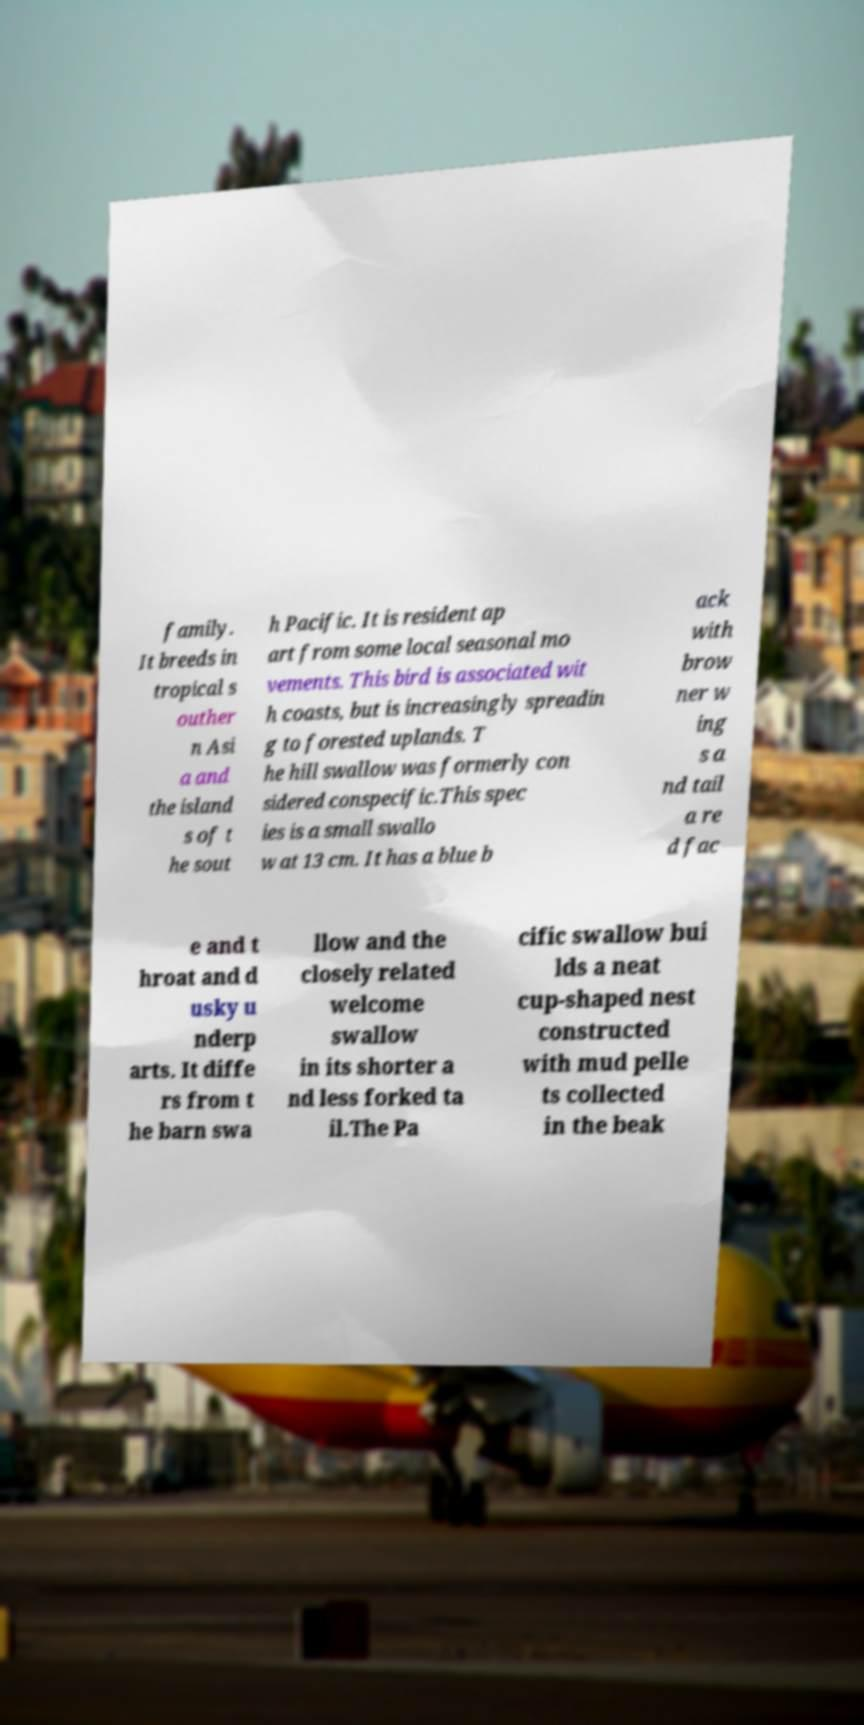I need the written content from this picture converted into text. Can you do that? family. It breeds in tropical s outher n Asi a and the island s of t he sout h Pacific. It is resident ap art from some local seasonal mo vements. This bird is associated wit h coasts, but is increasingly spreadin g to forested uplands. T he hill swallow was formerly con sidered conspecific.This spec ies is a small swallo w at 13 cm. It has a blue b ack with brow ner w ing s a nd tail a re d fac e and t hroat and d usky u nderp arts. It diffe rs from t he barn swa llow and the closely related welcome swallow in its shorter a nd less forked ta il.The Pa cific swallow bui lds a neat cup-shaped nest constructed with mud pelle ts collected in the beak 